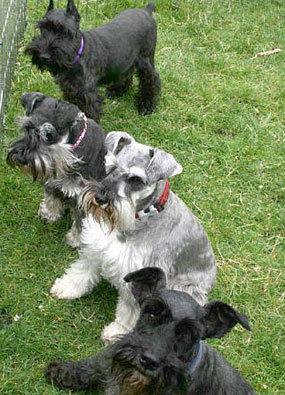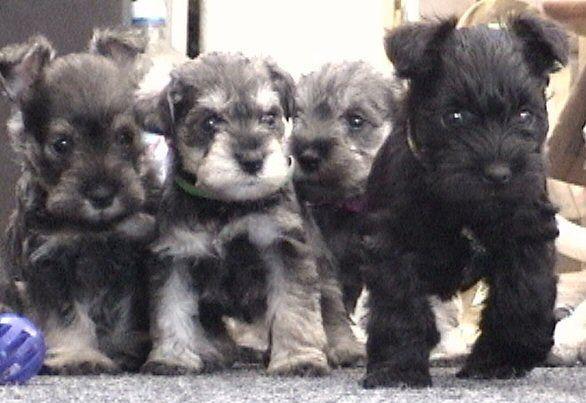The first image is the image on the left, the second image is the image on the right. Evaluate the accuracy of this statement regarding the images: "There are at least 4 black, gray and white puppies.". Is it true? Answer yes or no. Yes. The first image is the image on the left, the second image is the image on the right. Given the left and right images, does the statement "There are four dogs total." hold true? Answer yes or no. No. 